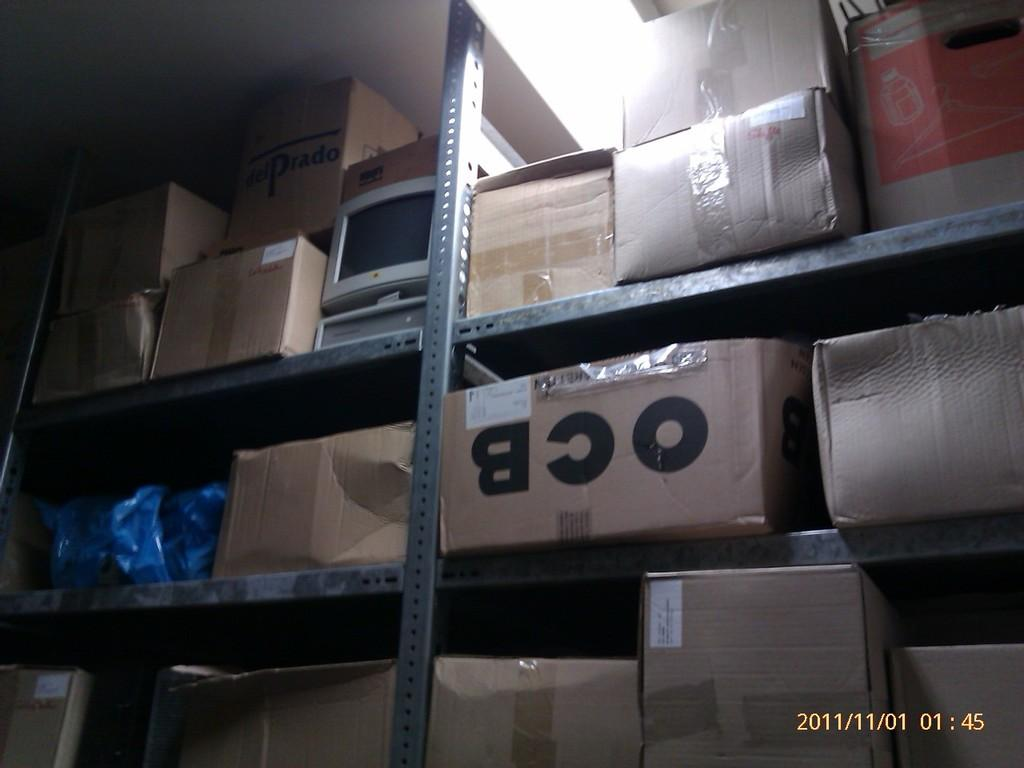What type of storage system is shown in the image? There are storage racks in the image. What can be found on each of the storage racks? Each rack contains boxes. What time is displayed on the clock in the image? There is no clock present in the image. What emotion is being expressed by the boxes in the image? The boxes do not express emotions; they are inanimate objects. 